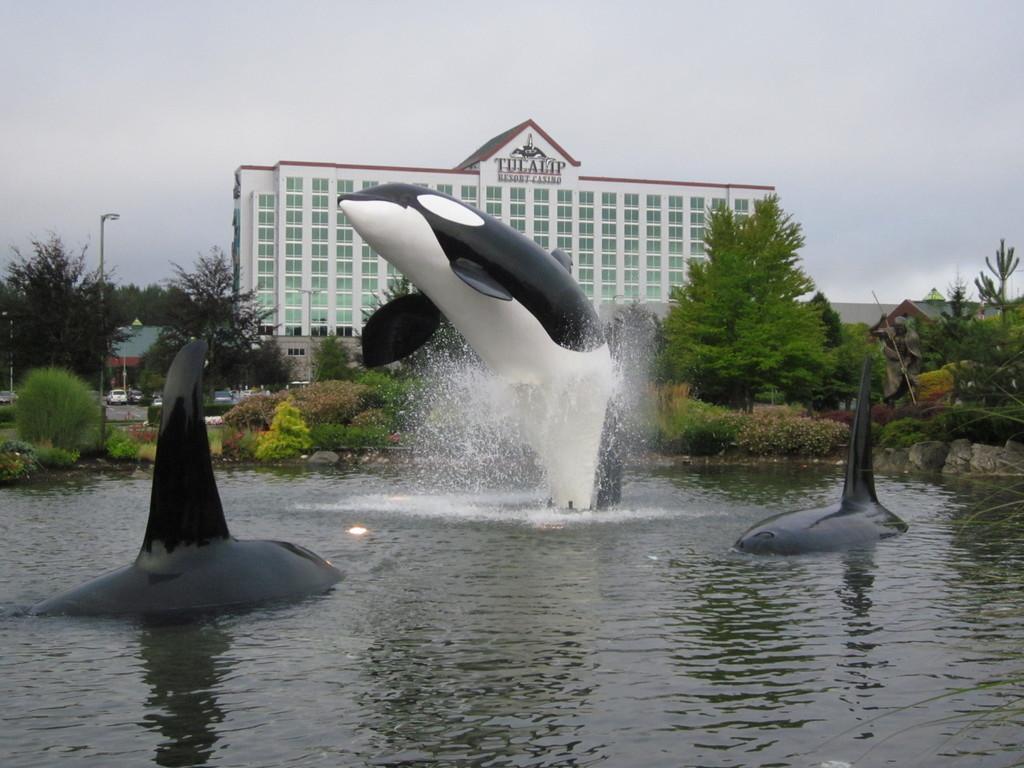Could you give a brief overview of what you see in this image? In this image, we can see some dolphin fishes in the water, there are some plants and trees, there is a building, at the top we can see the sky. 